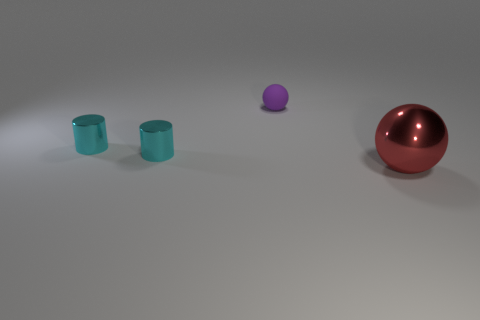Add 2 tiny purple rubber objects. How many objects exist? 6 Add 4 large shiny balls. How many large shiny balls are left? 5 Add 4 large green cylinders. How many large green cylinders exist? 4 Subtract 0 cyan blocks. How many objects are left? 4 Subtract all matte things. Subtract all shiny things. How many objects are left? 0 